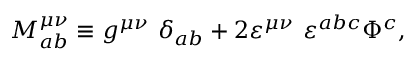Convert formula to latex. <formula><loc_0><loc_0><loc_500><loc_500>M _ { a b } ^ { \mu \nu } \equiv g ^ { \mu \nu } \delta _ { a b } + 2 \varepsilon ^ { \mu \nu } \varepsilon ^ { a b c } \Phi ^ { c } ,</formula> 